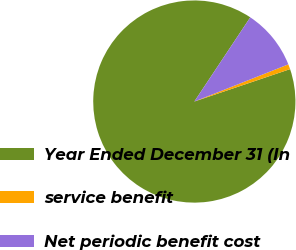Convert chart to OTSL. <chart><loc_0><loc_0><loc_500><loc_500><pie_chart><fcel>Year Ended December 31 (In<fcel>service benefit<fcel>Net periodic benefit cost<nl><fcel>89.53%<fcel>0.8%<fcel>9.67%<nl></chart> 